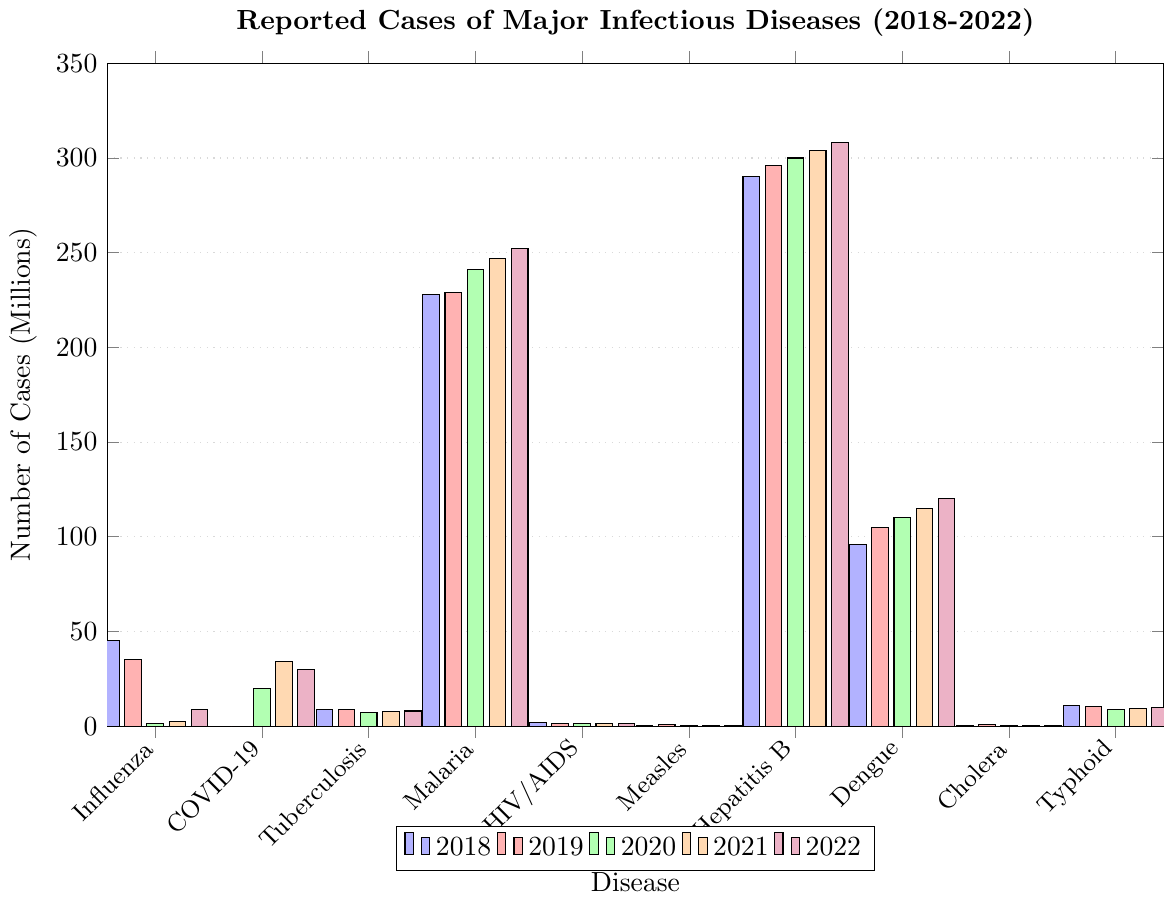Which disease had the highest number of cases reported in 2022? By observing the heights of the bars corresponding to 2022, Hepatitis B had the highest bar in 2022, indicating the highest number of cases.
Answer: Hepatitis B What is the total number of Influenza cases reported from 2018 to 2022? Summing the values for Influenza for each year: 45M + 35M + 1.5M + 2.5M + 9M = 93M
Answer: 93 million How did the number of reported Tuberculosis cases change from 2018 to 2022? By comparing the heights of the bars for Tuberculosis from 2018 (9M) and 2022 (8M), there's a slight decrease.
Answer: Decreased Which year had the highest number of COVID-19 cases? Observing the year with the tallest bar for COVID-19, 2021 had the highest number of COVID-19 cases.
Answer: 2021 How does the number of Malaria cases in 2020 compare to the number in 2022? The height of the bars for Malaria in 2020 (241M) and 2022 (252M) indicate that cases increased.
Answer: Increased What is the total number of reported Measles cases from 2019 to 2022? Summing the values for Measles from 2019 to 2022: 0.869M + 0.084M + 0.059M + 0.075M = 1.087M
Answer: 1.087 million Which disease showed a consistent increase in the number of reported cases from 2018 to 2022? By examining the trends for each disease, Dengue cases consistently increased each year from 2018 (96M) to 2022 (120M).
Answer: Dengue What was the average number of Cholera cases reported between 2019 and 2022? Summing the Cholera cases for these years: 0.923M (2019) + 0.08M (2020) + 0.11M (2021) + 0.15M (2022) = 1.263M. Dividing by 4 gives 1.263M / 4 = 0.31575M.
Answer: 0.316 million Which year had the highest overall number of reported infectious disease cases? Adding up the cases for all diseases by year, 2022 has the highest sum with significant contributions from Hepatitis B and Malaria, among others.
Answer: 2022 Compare the trend in reported Typhoid cases to the trend in reported HIV/AIDS cases from 2018 to 2022. Typhoid cases show an overall decreasing trend, going from 11M in 2018 to 10M in 2022. HIV/AIDS cases show a consistent decline as well, from 1.7M in 2018 to 1.3M in 2022. Both diseases show a downward trend.
Answer: Both show a downward trend 